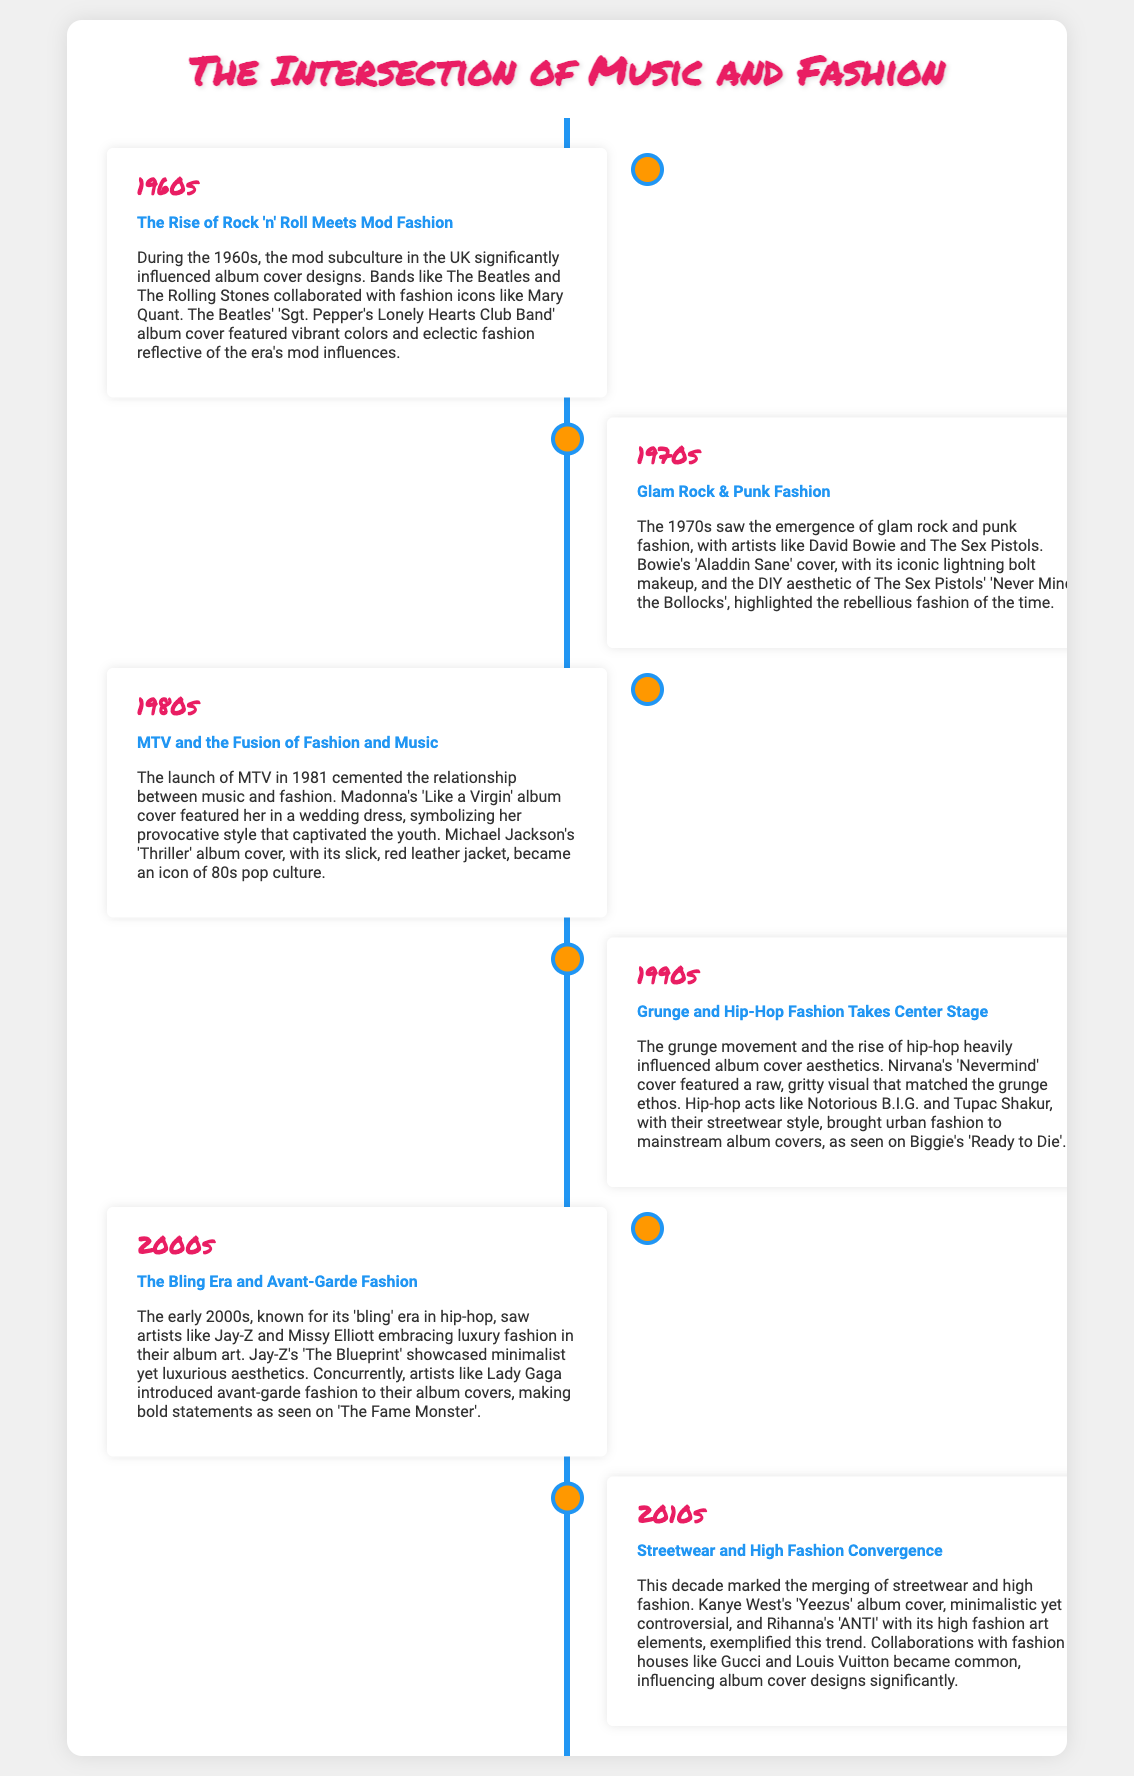What decade featured the rise of rock 'n' roll and mod fashion? The 1960s was known for the rise of rock 'n' roll and mod fashion, as stated in the entry for that decade.
Answer: 1960s Which album cover is associated with David Bowie in the 1970s? The document mentions David Bowie's 'Aladdin Sane' as the associated album cover from the 1970s.
Answer: Aladdin Sane What iconic fashion item is featured on Michael Jackson's 'Thriller' album cover? The 'Thriller' album cover is noted for its slick, red leather jacket, making this item iconic in 80s pop culture.
Answer: Red leather jacket What movement influenced Nirvana's 'Nevermind' album cover? The grunge movement heavily influenced the aesthetics of the 'Nevermind' cover, which is specified in the document.
Answer: Grunge movement In which decade did Kanye West's 'Yeezus' album cover emerge? Kanye West's 'Yeezus' album cover is mentioned in the entry for the 2010s as part of the style convergence.
Answer: 2010s How did collaboration with fashion houses impact album cover designs in the 2010s? The document states that collaborations with fashion houses like Gucci and Louis Vuitton became common, influencing album cover designs significantly.
Answer: Collaborations with fashion houses What was the defining fashion trend in the early 2000s? The document refers to the early 2000s as known for its 'bling' era in hip-hop.
Answer: Bling era Which artist's album cover featured a wedding dress? Madonna is noted for featuring a wedding dress on her 'Like a Virgin' album cover, as indicated in the 1980s section.
Answer: Madonna What does the 1990s entry associate with hip-hop fashion? The 1990s entry associates hip-hop fashion with artists like Notorious B.I.G. and Tupac Shakur, specifically noting their streetwear style.
Answer: Notorious B.I.G. and Tupac Shakur 